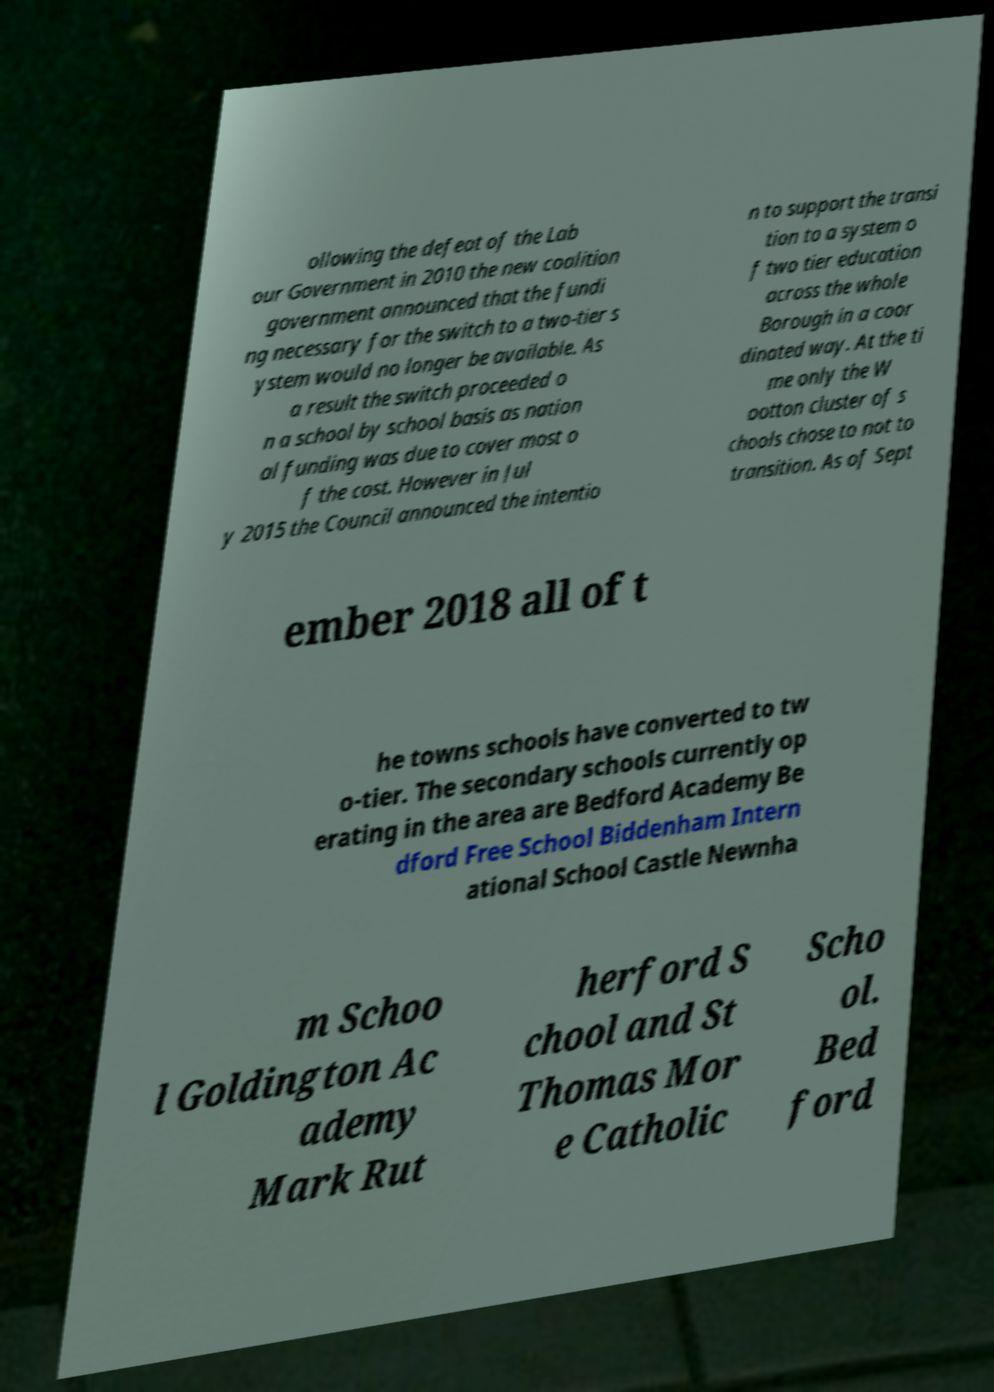There's text embedded in this image that I need extracted. Can you transcribe it verbatim? ollowing the defeat of the Lab our Government in 2010 the new coalition government announced that the fundi ng necessary for the switch to a two-tier s ystem would no longer be available. As a result the switch proceeded o n a school by school basis as nation al funding was due to cover most o f the cost. However in Jul y 2015 the Council announced the intentio n to support the transi tion to a system o f two tier education across the whole Borough in a coor dinated way. At the ti me only the W ootton cluster of s chools chose to not to transition. As of Sept ember 2018 all of t he towns schools have converted to tw o-tier. The secondary schools currently op erating in the area are Bedford Academy Be dford Free School Biddenham Intern ational School Castle Newnha m Schoo l Goldington Ac ademy Mark Rut herford S chool and St Thomas Mor e Catholic Scho ol. Bed ford 